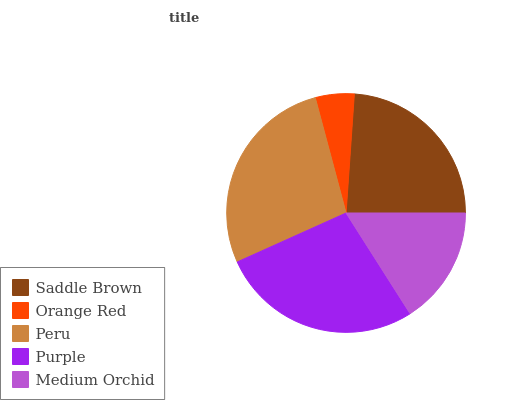Is Orange Red the minimum?
Answer yes or no. Yes. Is Peru the maximum?
Answer yes or no. Yes. Is Peru the minimum?
Answer yes or no. No. Is Orange Red the maximum?
Answer yes or no. No. Is Peru greater than Orange Red?
Answer yes or no. Yes. Is Orange Red less than Peru?
Answer yes or no. Yes. Is Orange Red greater than Peru?
Answer yes or no. No. Is Peru less than Orange Red?
Answer yes or no. No. Is Saddle Brown the high median?
Answer yes or no. Yes. Is Saddle Brown the low median?
Answer yes or no. Yes. Is Peru the high median?
Answer yes or no. No. Is Orange Red the low median?
Answer yes or no. No. 